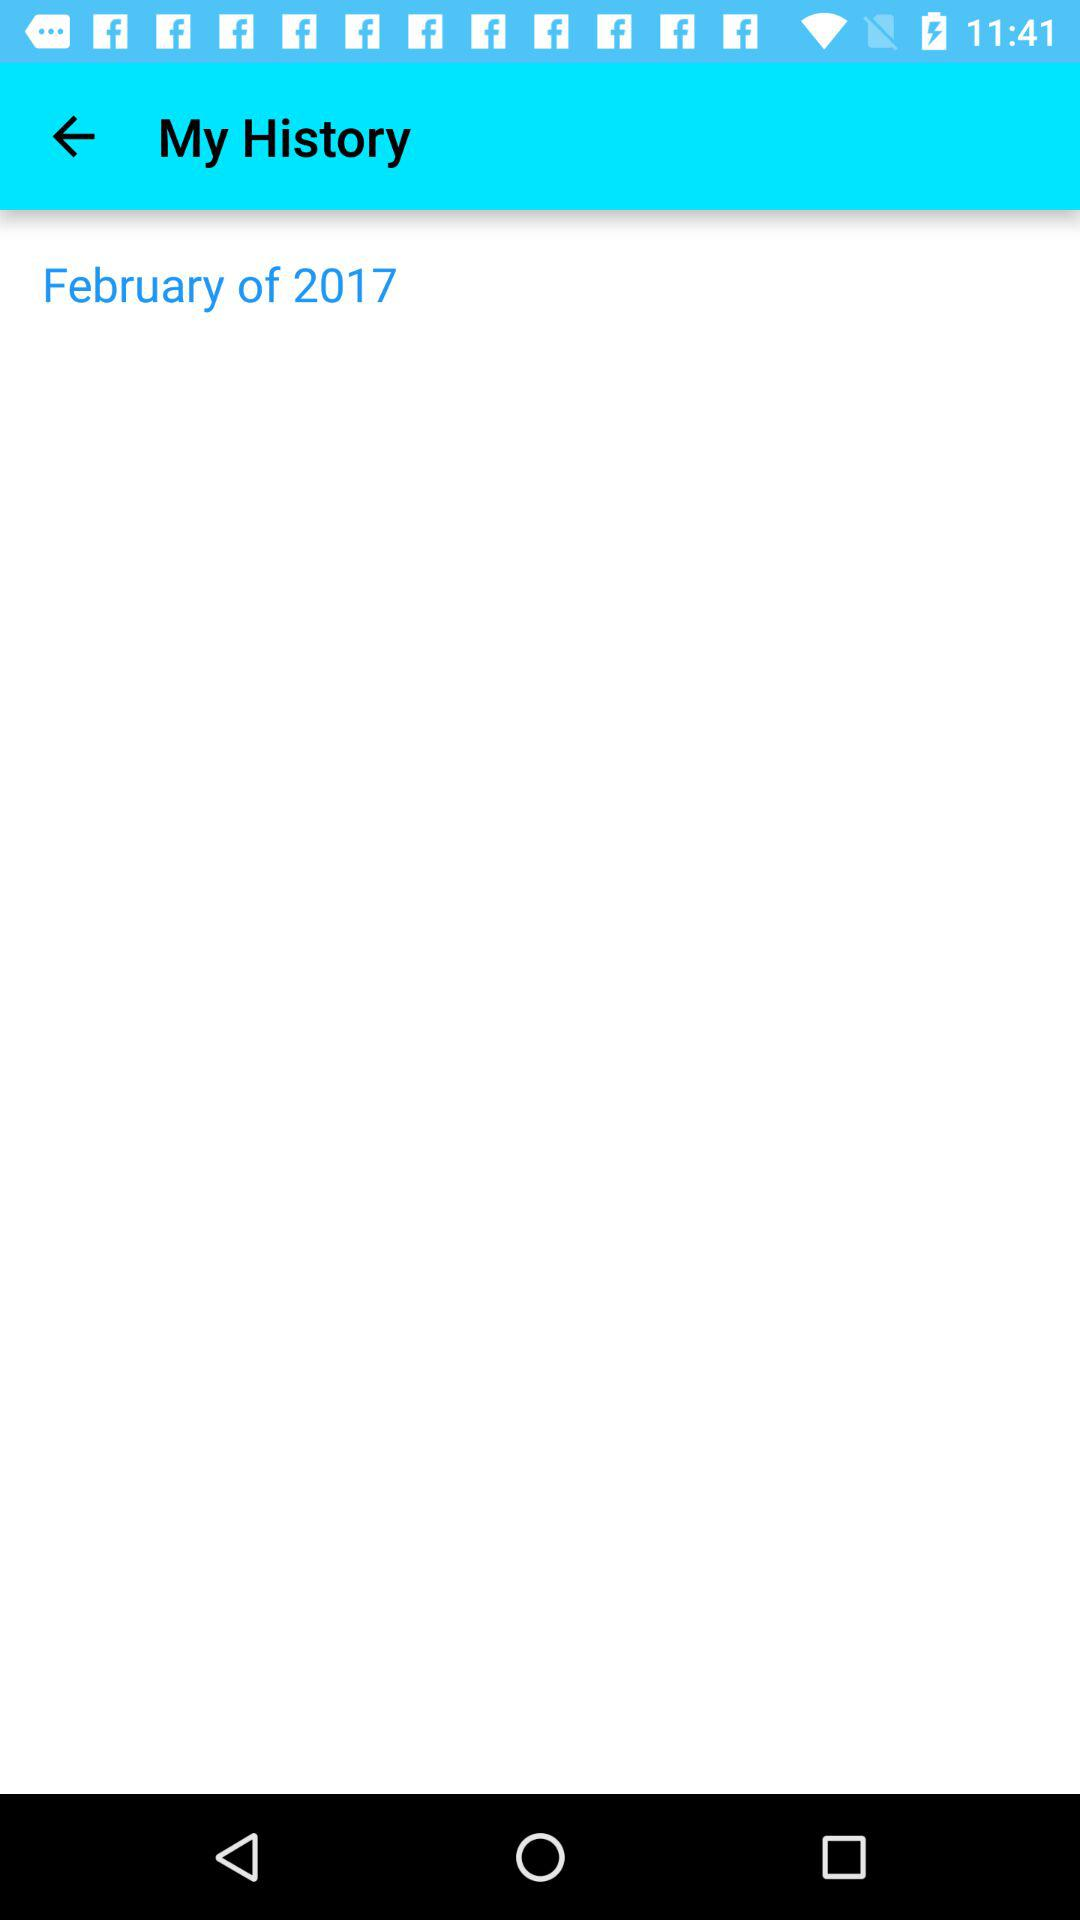What month is mentioned? The mentioned month is February. 